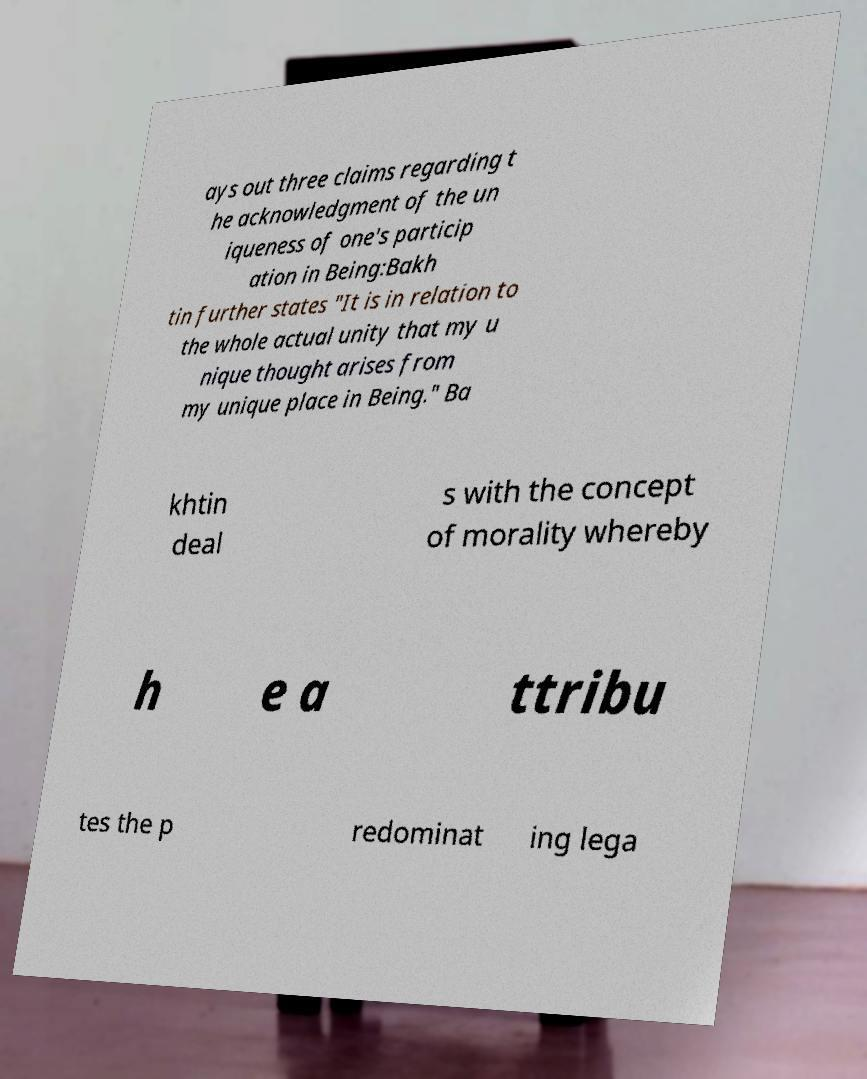Can you read and provide the text displayed in the image?This photo seems to have some interesting text. Can you extract and type it out for me? ays out three claims regarding t he acknowledgment of the un iqueness of one's particip ation in Being:Bakh tin further states "It is in relation to the whole actual unity that my u nique thought arises from my unique place in Being." Ba khtin deal s with the concept of morality whereby h e a ttribu tes the p redominat ing lega 